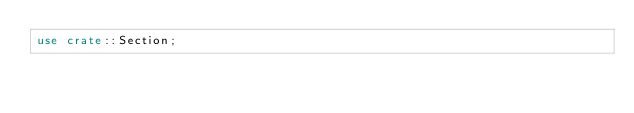<code> <loc_0><loc_0><loc_500><loc_500><_Rust_>use crate::Section;</code> 